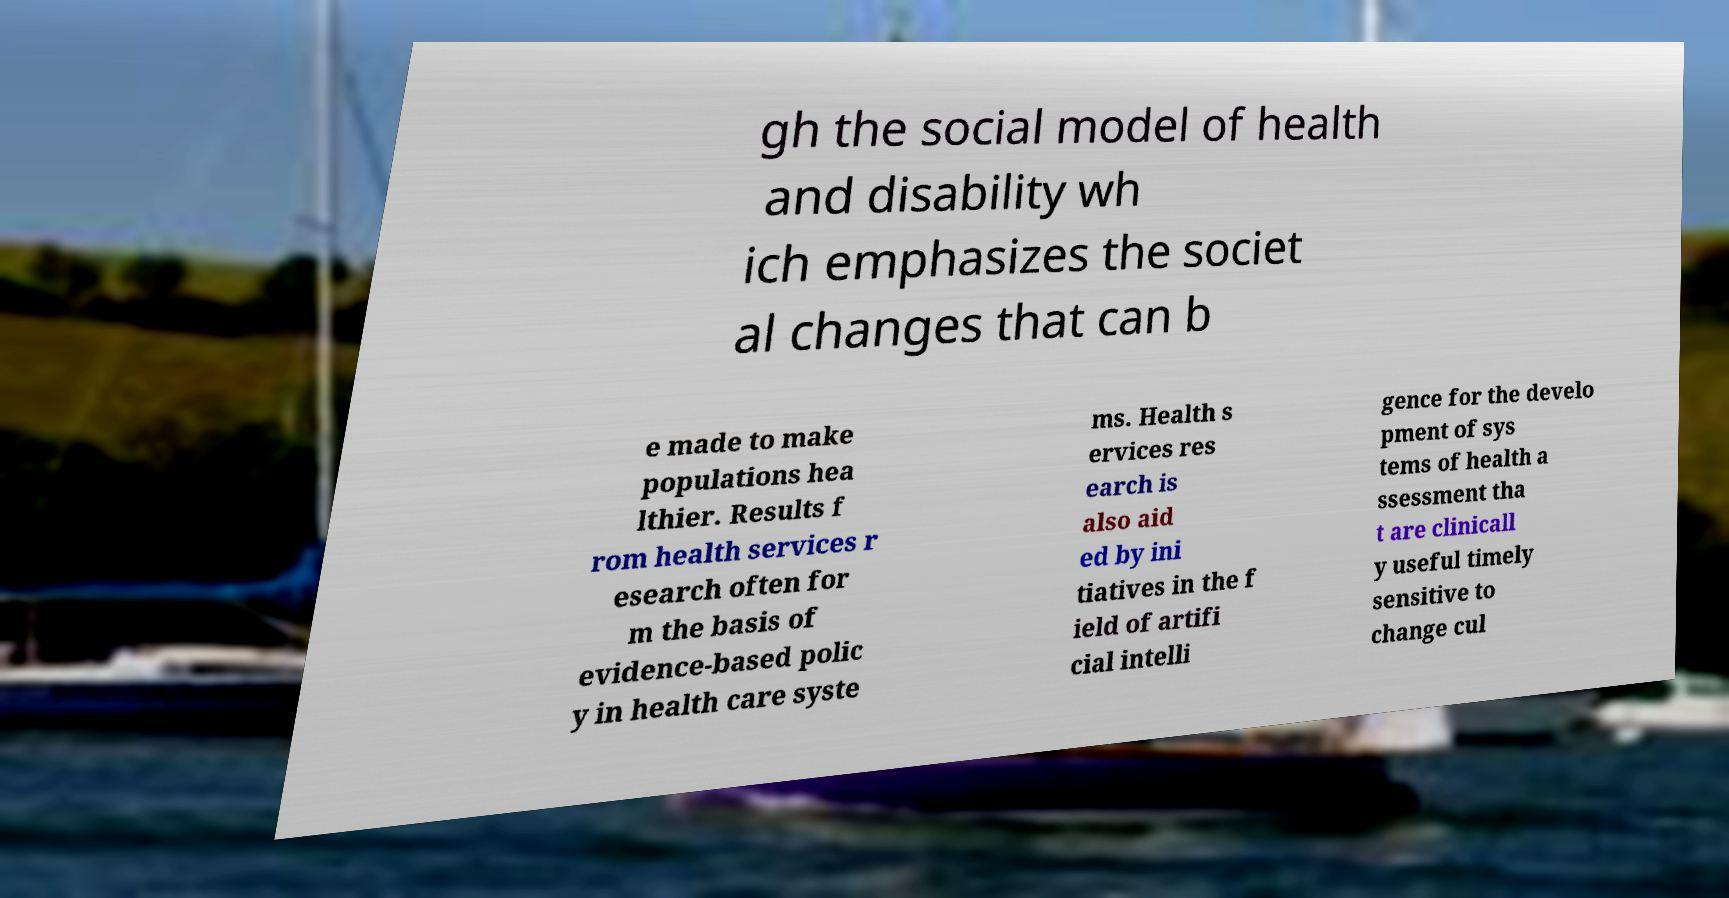For documentation purposes, I need the text within this image transcribed. Could you provide that? gh the social model of health and disability wh ich emphasizes the societ al changes that can b e made to make populations hea lthier. Results f rom health services r esearch often for m the basis of evidence-based polic y in health care syste ms. Health s ervices res earch is also aid ed by ini tiatives in the f ield of artifi cial intelli gence for the develo pment of sys tems of health a ssessment tha t are clinicall y useful timely sensitive to change cul 